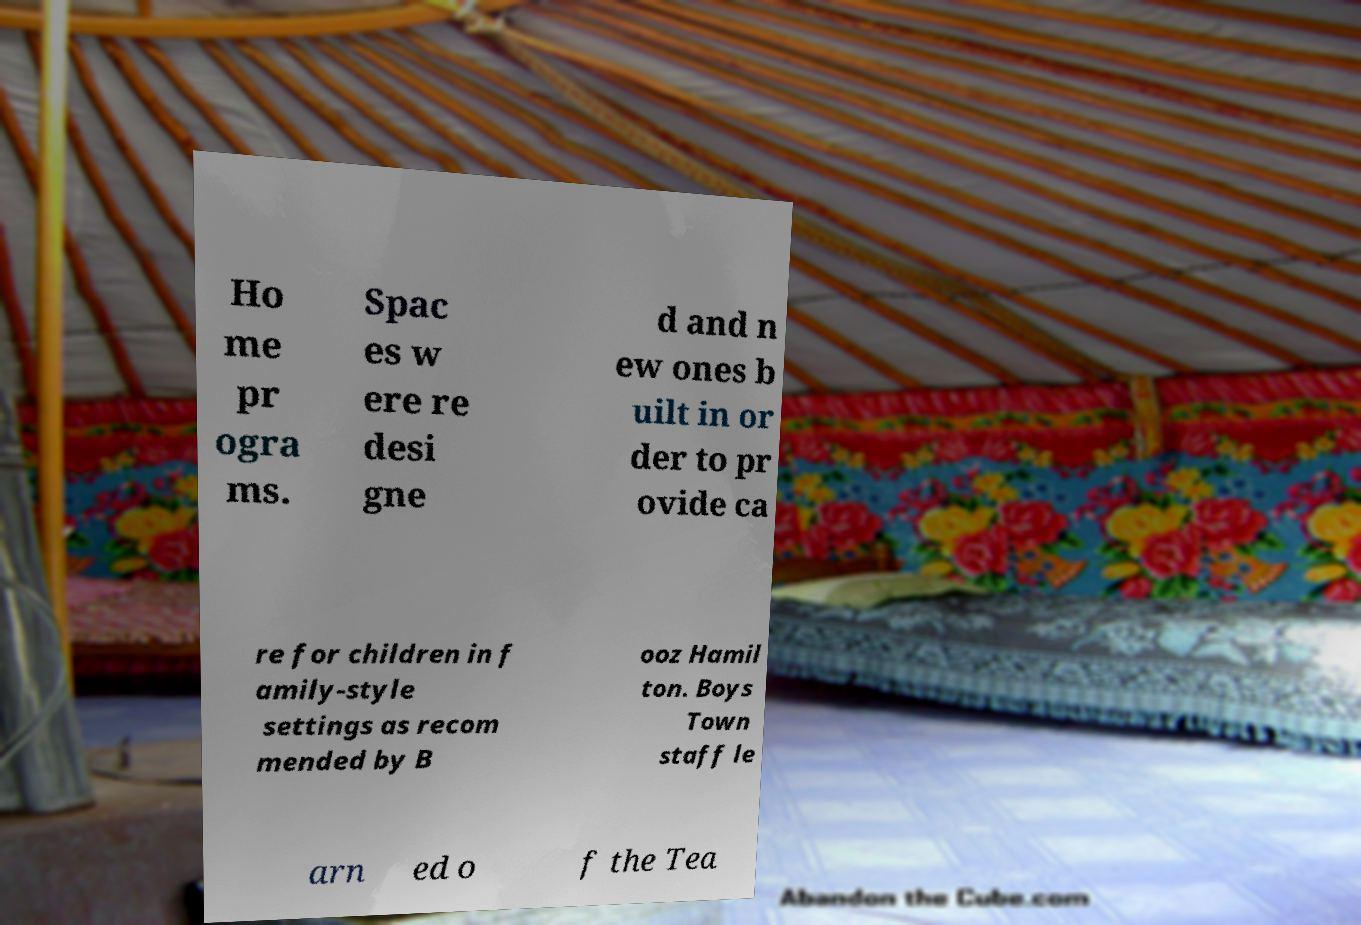Please identify and transcribe the text found in this image. Ho me pr ogra ms. Spac es w ere re desi gne d and n ew ones b uilt in or der to pr ovide ca re for children in f amily-style settings as recom mended by B ooz Hamil ton. Boys Town staff le arn ed o f the Tea 